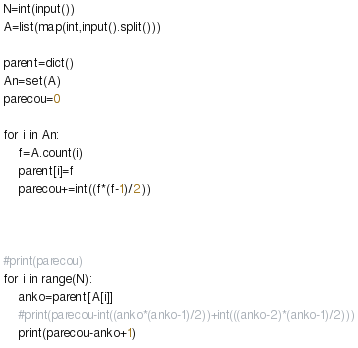Convert code to text. <code><loc_0><loc_0><loc_500><loc_500><_Python_>N=int(input())
A=list(map(int,input().split()))

parent=dict()
An=set(A)
parecou=0

for i in An:
    f=A.count(i)
    parent[i]=f
    parecou+=int((f*(f-1)/2))



#print(parecou)
for i in range(N):
    anko=parent[A[i]]
    #print(parecou-int((anko*(anko-1)/2))+int(((anko-2)*(anko-1)/2)))
    print(parecou-anko+1)
</code> 